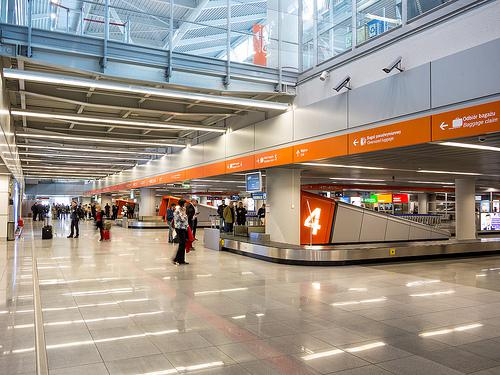Question: where was this picture taken?
Choices:
A. Baggage claim section.
B. Section of airport.
C. Claiming section of airport.
D. Baggage claim at an airport.
Answer with the letter. Answer: D Question: what are the people waiting for?
Choices:
A. To claim their luggage.
B. To get their items.
C. To claim their belongings.
D. To get to the next part of their trip.
Answer with the letter. Answer: A Question: what background color is the signage?
Choices:
A. Orange.
B. Red.
C. Yellow.
D. Warm colors.
Answer with the letter. Answer: A Question: when can passengers leave the area?
Choices:
A. After they are done.
B. When they are ready to leave.
C. After they've shown their claim tickets.
D. When they want to go home.
Answer with the letter. Answer: C Question: who will check the claim tickets?
Choices:
A. A security guard.
B. A ticket specialist.
C. A ticket checker.
D. An airport employee.
Answer with the letter. Answer: D Question: what carousel are the people waiting at?
Choices:
A. Number five.
B. Number six.
C. Number four.
D. Number seven.
Answer with the letter. Answer: C Question: how will people know when the luggage is coming?
Choices:
A. A light will go on and an alarm will sound.
B. A light will emit.
C. A sound will emit.
D. A notification will appear.
Answer with the letter. Answer: A 